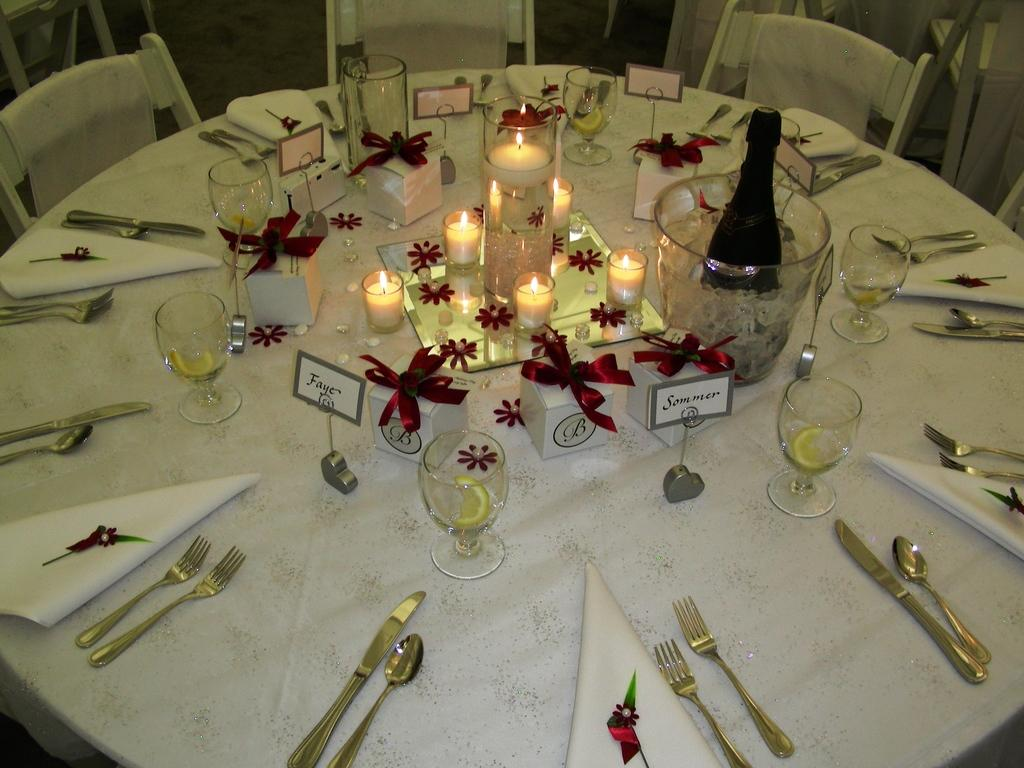What type of furniture is present in the image? There are chairs and a table in the image. What items can be seen on the table? There are candles, a bottle, glasses, gift boxes, a cloth, a knife, a spoon, a fork, and a container on the table. What might be used for cutting in the image? There is a knife on the table. What might be used for stirring or serving in the image? There is a spoon on the table. What might be used for eating in the image? There is a fork on the table. Can you tell me where the father is sitting in the image? There is no mention of a father or anyone sitting in the image. What does the creator of the table look like? The creator of the table is not present in the image, and their appearance cannot be determined. 